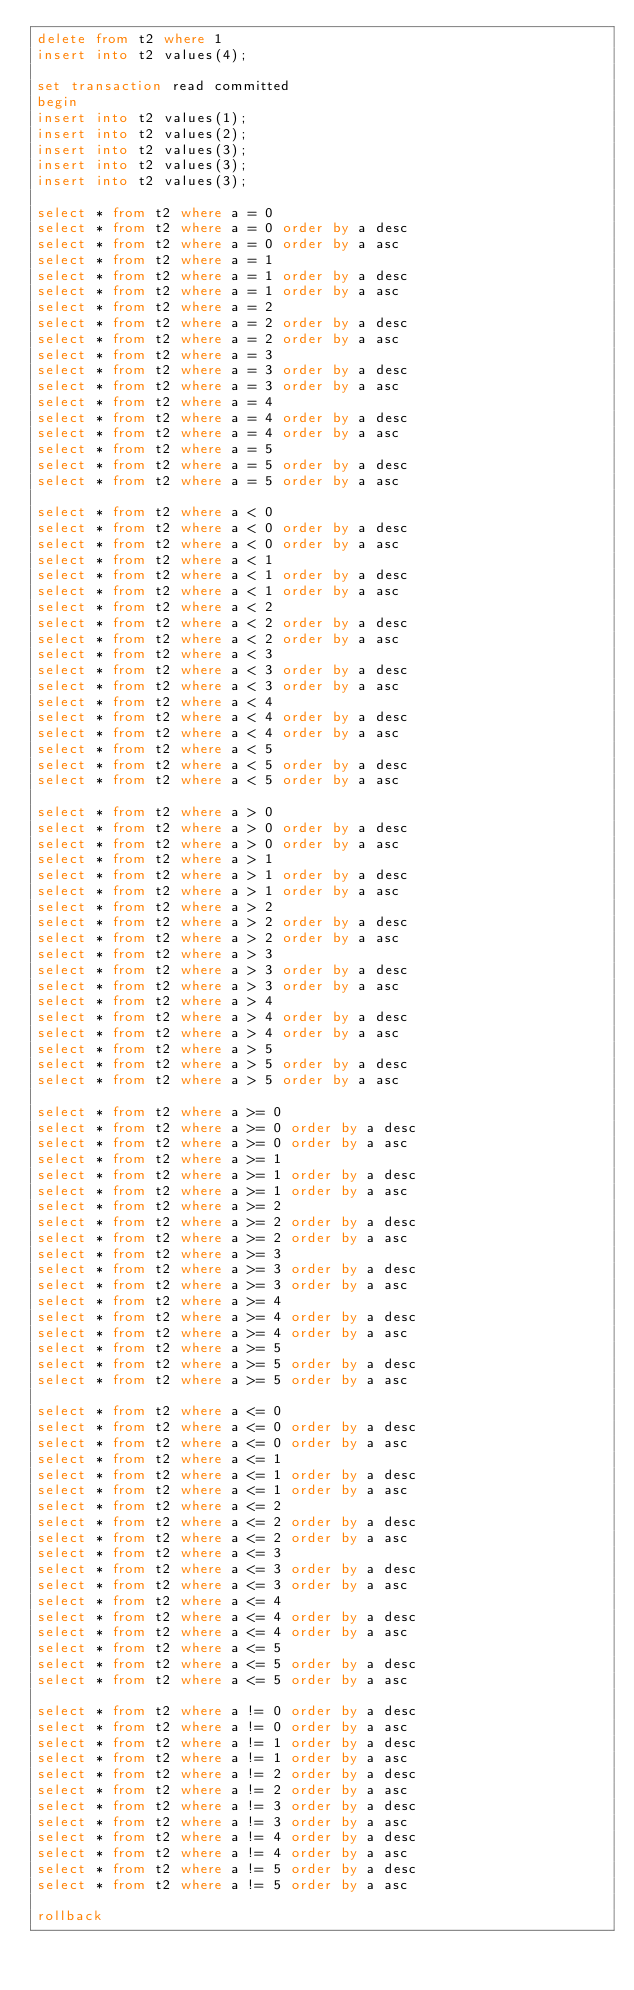<code> <loc_0><loc_0><loc_500><loc_500><_SQL_>delete from t2 where 1
insert into t2 values(4);

set transaction read committed
begin
insert into t2 values(1);
insert into t2 values(2);
insert into t2 values(3);
insert into t2 values(3);
insert into t2 values(3);

select * from t2 where a = 0
select * from t2 where a = 0 order by a desc
select * from t2 where a = 0 order by a asc
select * from t2 where a = 1
select * from t2 where a = 1 order by a desc
select * from t2 where a = 1 order by a asc
select * from t2 where a = 2
select * from t2 where a = 2 order by a desc
select * from t2 where a = 2 order by a asc
select * from t2 where a = 3
select * from t2 where a = 3 order by a desc
select * from t2 where a = 3 order by a asc
select * from t2 where a = 4
select * from t2 where a = 4 order by a desc
select * from t2 where a = 4 order by a asc
select * from t2 where a = 5
select * from t2 where a = 5 order by a desc
select * from t2 where a = 5 order by a asc

select * from t2 where a < 0
select * from t2 where a < 0 order by a desc
select * from t2 where a < 0 order by a asc
select * from t2 where a < 1
select * from t2 where a < 1 order by a desc
select * from t2 where a < 1 order by a asc
select * from t2 where a < 2
select * from t2 where a < 2 order by a desc
select * from t2 where a < 2 order by a asc
select * from t2 where a < 3
select * from t2 where a < 3 order by a desc
select * from t2 where a < 3 order by a asc
select * from t2 where a < 4
select * from t2 where a < 4 order by a desc
select * from t2 where a < 4 order by a asc
select * from t2 where a < 5
select * from t2 where a < 5 order by a desc
select * from t2 where a < 5 order by a asc

select * from t2 where a > 0
select * from t2 where a > 0 order by a desc
select * from t2 where a > 0 order by a asc
select * from t2 where a > 1
select * from t2 where a > 1 order by a desc
select * from t2 where a > 1 order by a asc
select * from t2 where a > 2
select * from t2 where a > 2 order by a desc
select * from t2 where a > 2 order by a asc
select * from t2 where a > 3
select * from t2 where a > 3 order by a desc
select * from t2 where a > 3 order by a asc
select * from t2 where a > 4
select * from t2 where a > 4 order by a desc
select * from t2 where a > 4 order by a asc
select * from t2 where a > 5
select * from t2 where a > 5 order by a desc
select * from t2 where a > 5 order by a asc

select * from t2 where a >= 0
select * from t2 where a >= 0 order by a desc
select * from t2 where a >= 0 order by a asc
select * from t2 where a >= 1
select * from t2 where a >= 1 order by a desc
select * from t2 where a >= 1 order by a asc
select * from t2 where a >= 2
select * from t2 where a >= 2 order by a desc
select * from t2 where a >= 2 order by a asc
select * from t2 where a >= 3
select * from t2 where a >= 3 order by a desc
select * from t2 where a >= 3 order by a asc
select * from t2 where a >= 4
select * from t2 where a >= 4 order by a desc
select * from t2 where a >= 4 order by a asc
select * from t2 where a >= 5
select * from t2 where a >= 5 order by a desc
select * from t2 where a >= 5 order by a asc

select * from t2 where a <= 0
select * from t2 where a <= 0 order by a desc
select * from t2 where a <= 0 order by a asc
select * from t2 where a <= 1
select * from t2 where a <= 1 order by a desc
select * from t2 where a <= 1 order by a asc
select * from t2 where a <= 2
select * from t2 where a <= 2 order by a desc
select * from t2 where a <= 2 order by a asc
select * from t2 where a <= 3
select * from t2 where a <= 3 order by a desc
select * from t2 where a <= 3 order by a asc
select * from t2 where a <= 4
select * from t2 where a <= 4 order by a desc
select * from t2 where a <= 4 order by a asc
select * from t2 where a <= 5
select * from t2 where a <= 5 order by a desc
select * from t2 where a <= 5 order by a asc

select * from t2 where a != 0 order by a desc
select * from t2 where a != 0 order by a asc
select * from t2 where a != 1 order by a desc
select * from t2 where a != 1 order by a asc
select * from t2 where a != 2 order by a desc
select * from t2 where a != 2 order by a asc
select * from t2 where a != 3 order by a desc
select * from t2 where a != 3 order by a asc
select * from t2 where a != 4 order by a desc
select * from t2 where a != 4 order by a asc
select * from t2 where a != 5 order by a desc
select * from t2 where a != 5 order by a asc

rollback
</code> 